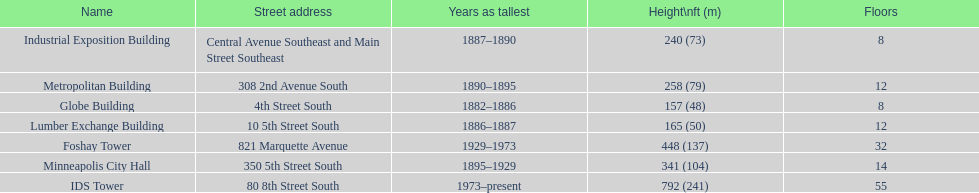Which building has the same number of floors as the lumber exchange building? Metropolitan Building. 